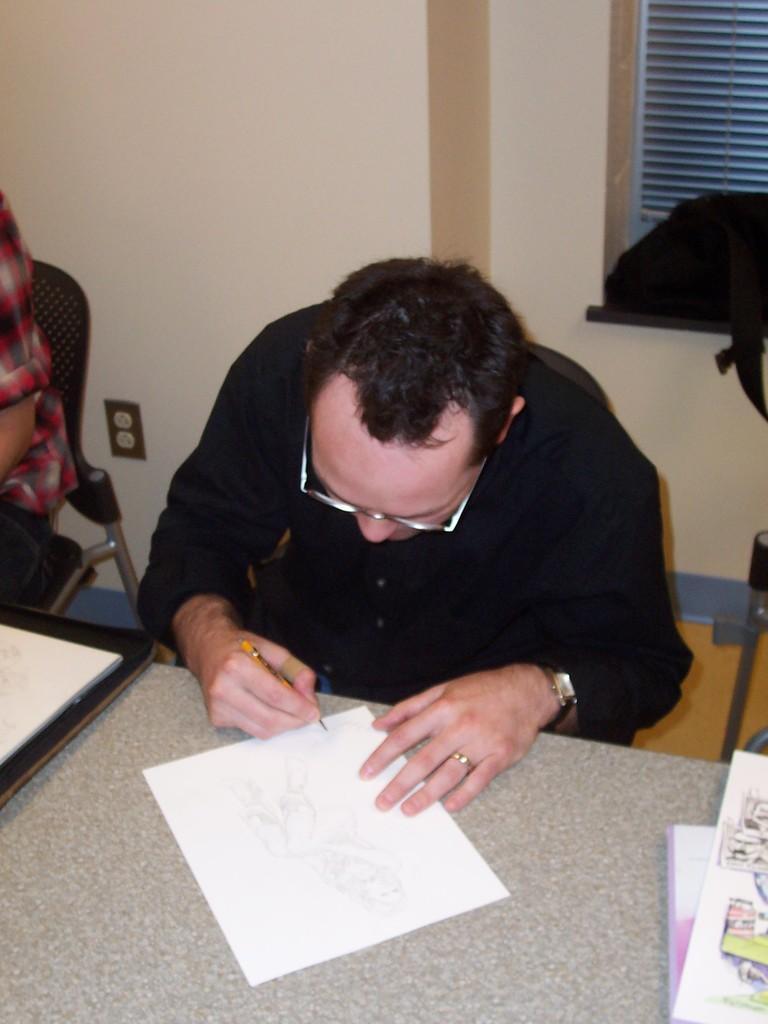How would you summarize this image in a sentence or two? This is the picture of a man sitting on a chair. The man is holding a pencil and drawing on the paper. The man having a ring to his right hand and watch also. Beside of the man there is other man who is sitting on a chair. Background of this two man is a wall. 